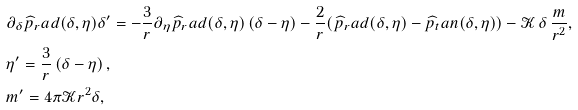Convert formula to latex. <formula><loc_0><loc_0><loc_500><loc_500>& \partial _ { \delta } \widehat { p } _ { r } a d ( \delta , \eta ) \delta ^ { \prime } = - \frac { 3 } { r } \partial _ { \eta } \widehat { p } _ { r } a d ( \delta , \eta ) \left ( \delta - \eta \right ) - \frac { 2 } { r } ( \widehat { p } _ { r } a d ( \delta , \eta ) - \widehat { p } _ { t } a n ( \delta , \eta ) ) - \mathcal { K } \, \delta \, \frac { m } { r ^ { 2 } } , \\ & \eta ^ { \prime } = \frac { 3 } { r } \left ( \delta - \eta \right ) , \\ & m ^ { \prime } = 4 \pi \mathcal { K } r ^ { 2 } \delta ,</formula> 